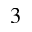<formula> <loc_0><loc_0><loc_500><loc_500>_ { 3 }</formula> 